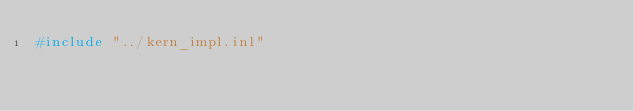Convert code to text. <code><loc_0><loc_0><loc_500><loc_500><_C++_>#include "../kern_impl.inl"
</code> 